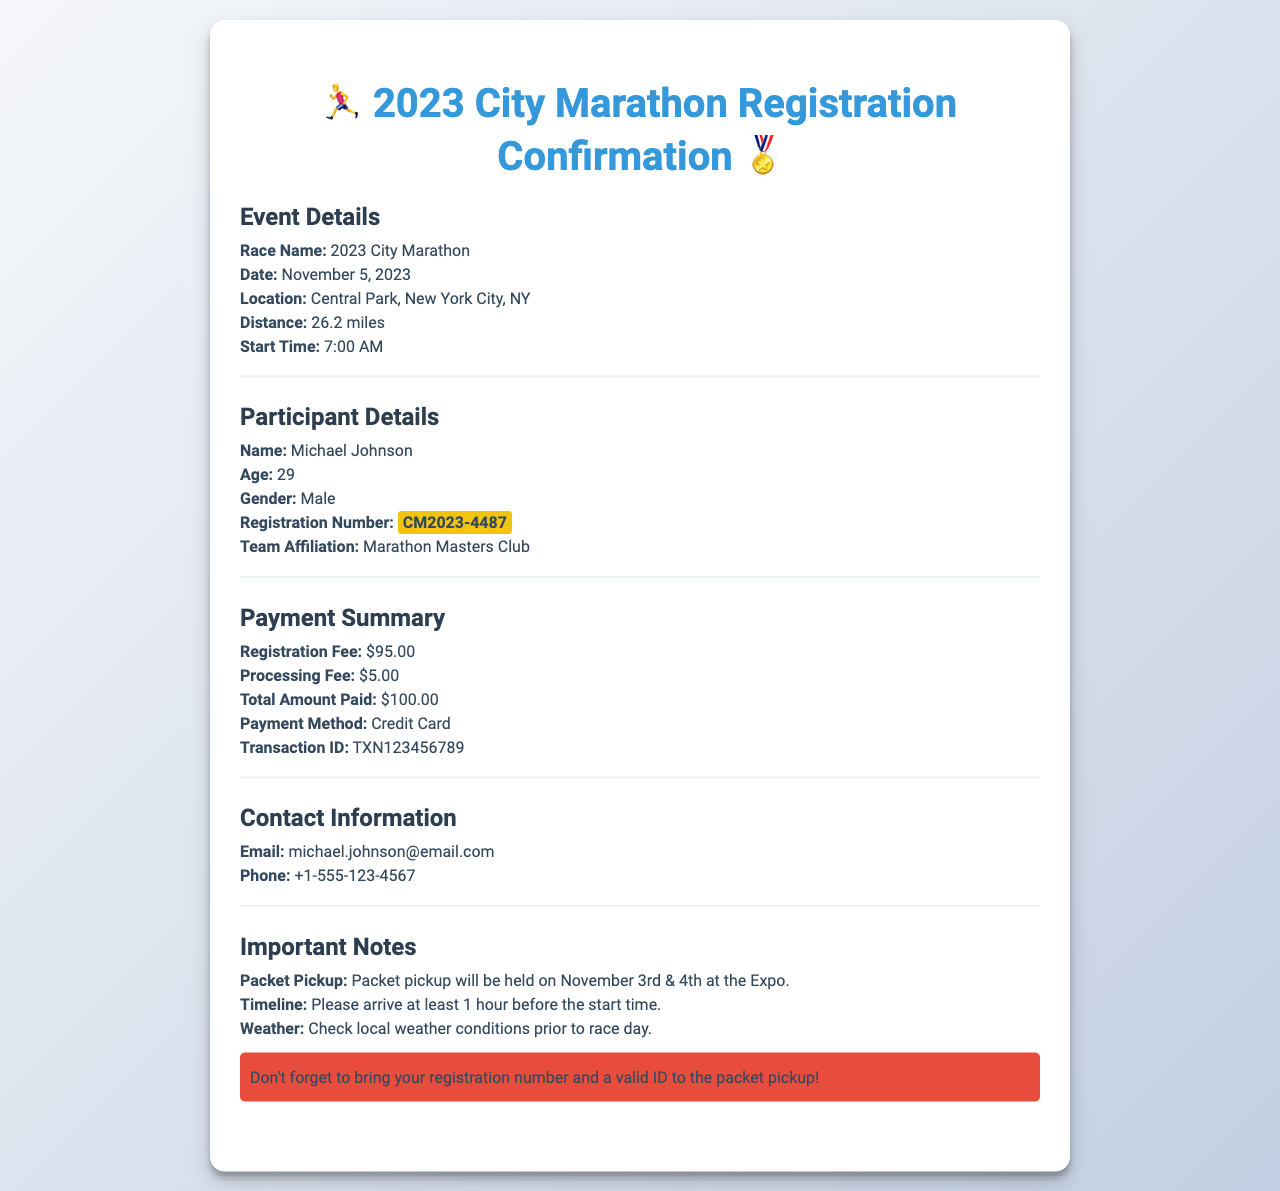what is the race name? The race name is stated at the beginning of the event details section.
Answer: 2023 City Marathon what is the date of the race? The date of the race is provided in the event details section.
Answer: November 5, 2023 who is the participant? The participant's name is listed in the participant details section.
Answer: Michael Johnson what is the total amount paid by the participant? The total amount paid is summarized in the payment summary section.
Answer: $100.00 what is the registration number? The registration number is highlighted in the participant details section.
Answer: CM2023-4487 what team is affiliated with the participant? The team is mentioned in the participant details section.
Answer: Marathon Masters Club how much is the registration fee? The registration fee is specified in the payment summary section.
Answer: $95.00 when is the packet pickup? The dates for packet pickup are provided in the important notes section.
Answer: November 3rd & 4th what is the payment method used? The payment method is detailed in the payment summary section.
Answer: Credit Card how early should participants arrive before the race? The recommended arrival time is specified in the important notes section.
Answer: 1 hour before the start time 